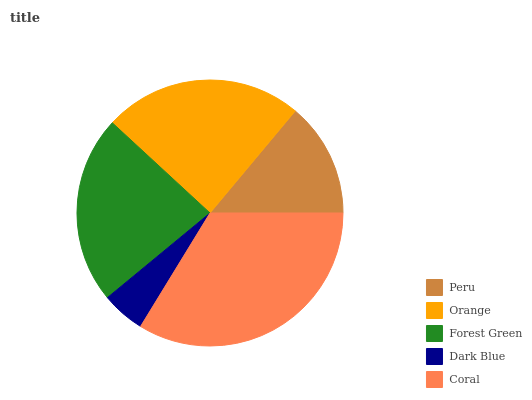Is Dark Blue the minimum?
Answer yes or no. Yes. Is Coral the maximum?
Answer yes or no. Yes. Is Orange the minimum?
Answer yes or no. No. Is Orange the maximum?
Answer yes or no. No. Is Orange greater than Peru?
Answer yes or no. Yes. Is Peru less than Orange?
Answer yes or no. Yes. Is Peru greater than Orange?
Answer yes or no. No. Is Orange less than Peru?
Answer yes or no. No. Is Forest Green the high median?
Answer yes or no. Yes. Is Forest Green the low median?
Answer yes or no. Yes. Is Peru the high median?
Answer yes or no. No. Is Dark Blue the low median?
Answer yes or no. No. 